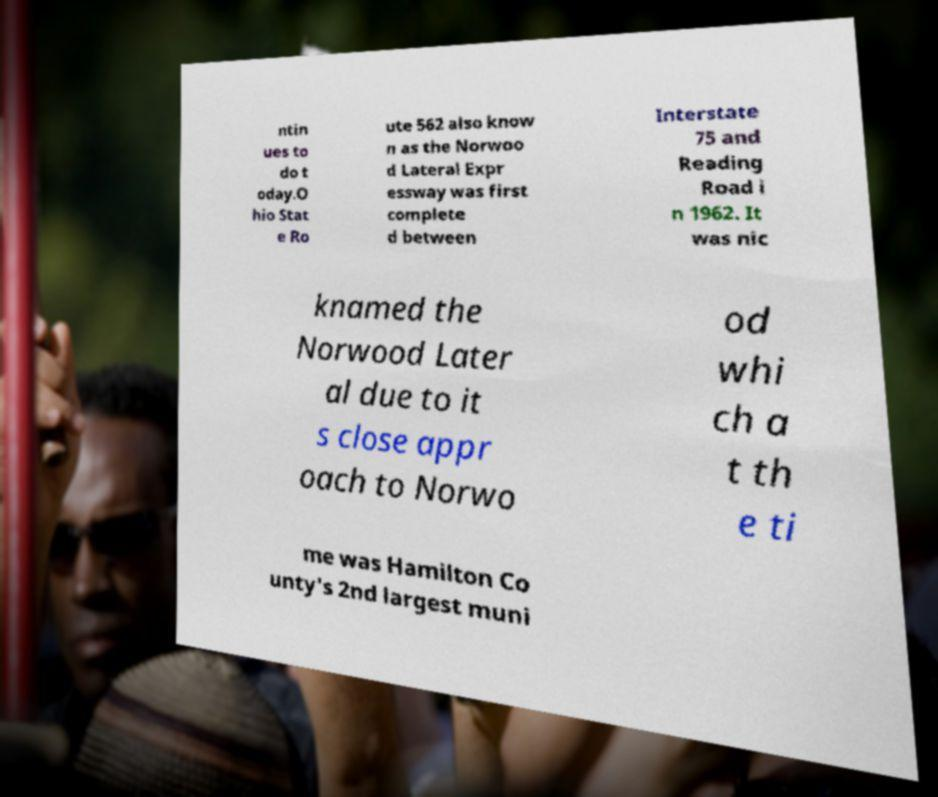For documentation purposes, I need the text within this image transcribed. Could you provide that? ntin ues to do t oday.O hio Stat e Ro ute 562 also know n as the Norwoo d Lateral Expr essway was first complete d between Interstate 75 and Reading Road i n 1962. It was nic knamed the Norwood Later al due to it s close appr oach to Norwo od whi ch a t th e ti me was Hamilton Co unty's 2nd largest muni 